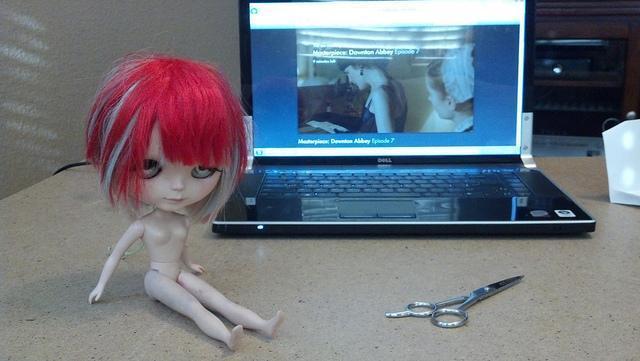How many people are there?
Give a very brief answer. 2. How many cows are away from the camera?
Give a very brief answer. 0. 